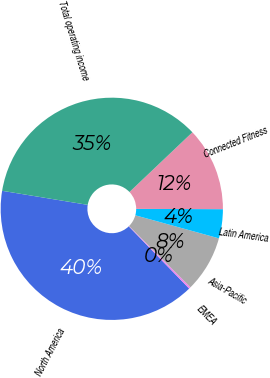<chart> <loc_0><loc_0><loc_500><loc_500><pie_chart><fcel>North America<fcel>EMEA<fcel>Asia-Pacific<fcel>Latin America<fcel>Connected Fitness<fcel>Total operating income<nl><fcel>39.85%<fcel>0.27%<fcel>8.19%<fcel>4.23%<fcel>12.14%<fcel>35.32%<nl></chart> 